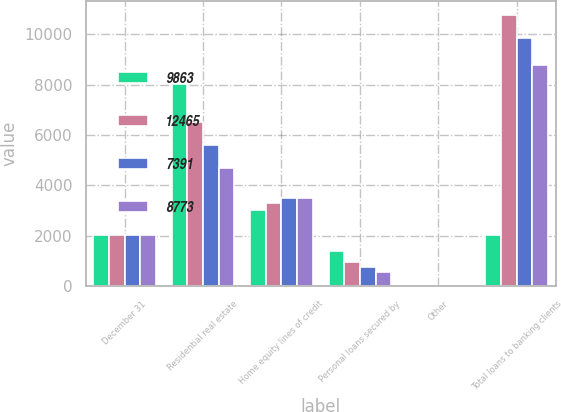Convert chart to OTSL. <chart><loc_0><loc_0><loc_500><loc_500><stacked_bar_chart><ecel><fcel>December 31<fcel>Residential real estate<fcel>Home equity lines of credit<fcel>Personal loans secured by<fcel>Other<fcel>Total loans to banking clients<nl><fcel>9863<fcel>2013<fcel>8006<fcel>3041<fcel>1384<fcel>34<fcel>2013<nl><fcel>12465<fcel>2012<fcel>6507<fcel>3287<fcel>963<fcel>22<fcel>10779<nl><fcel>7391<fcel>2011<fcel>5596<fcel>3509<fcel>742<fcel>16<fcel>9863<nl><fcel>8773<fcel>2010<fcel>4695<fcel>3500<fcel>562<fcel>16<fcel>8773<nl></chart> 